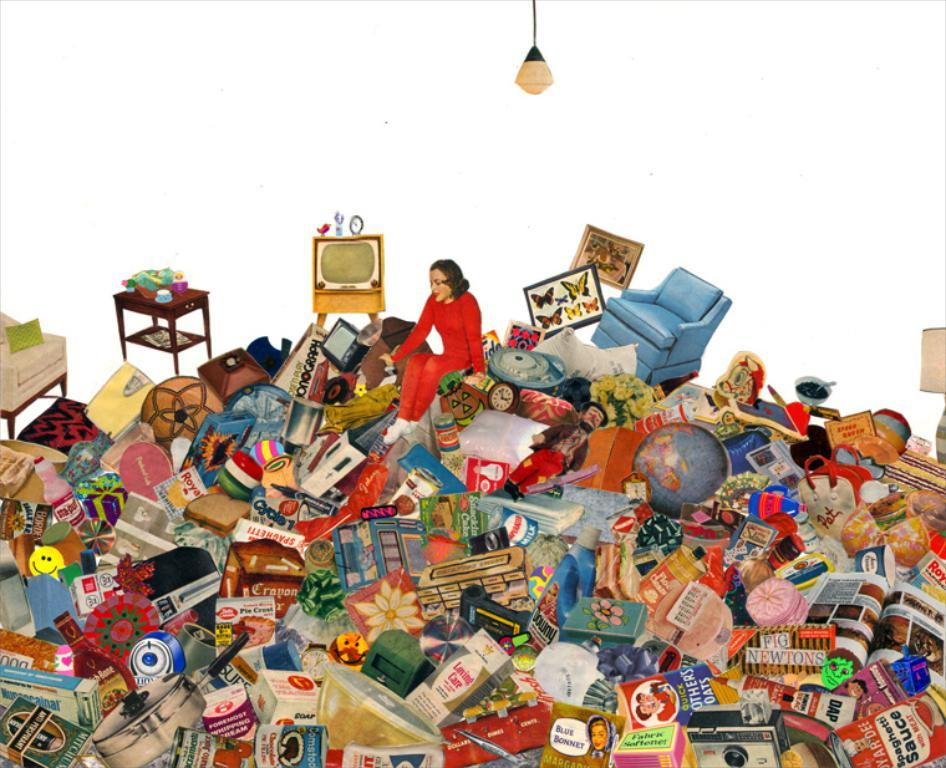What type of object is the toy in the image? There is a toy person in the image. What type of furniture is in the image? There is a couch in the image. What type of decorative item is in the image? There is a frame in the image. What type of electronic device is in the image? There is a television in the image. What type of light source is visible in the image? There is a light visible at the top of the image. How many trucks are visible in the image? There are no trucks present in the image. What color is the tongue of the toy person in the image? There is no tongue present on the toy person in the image. 